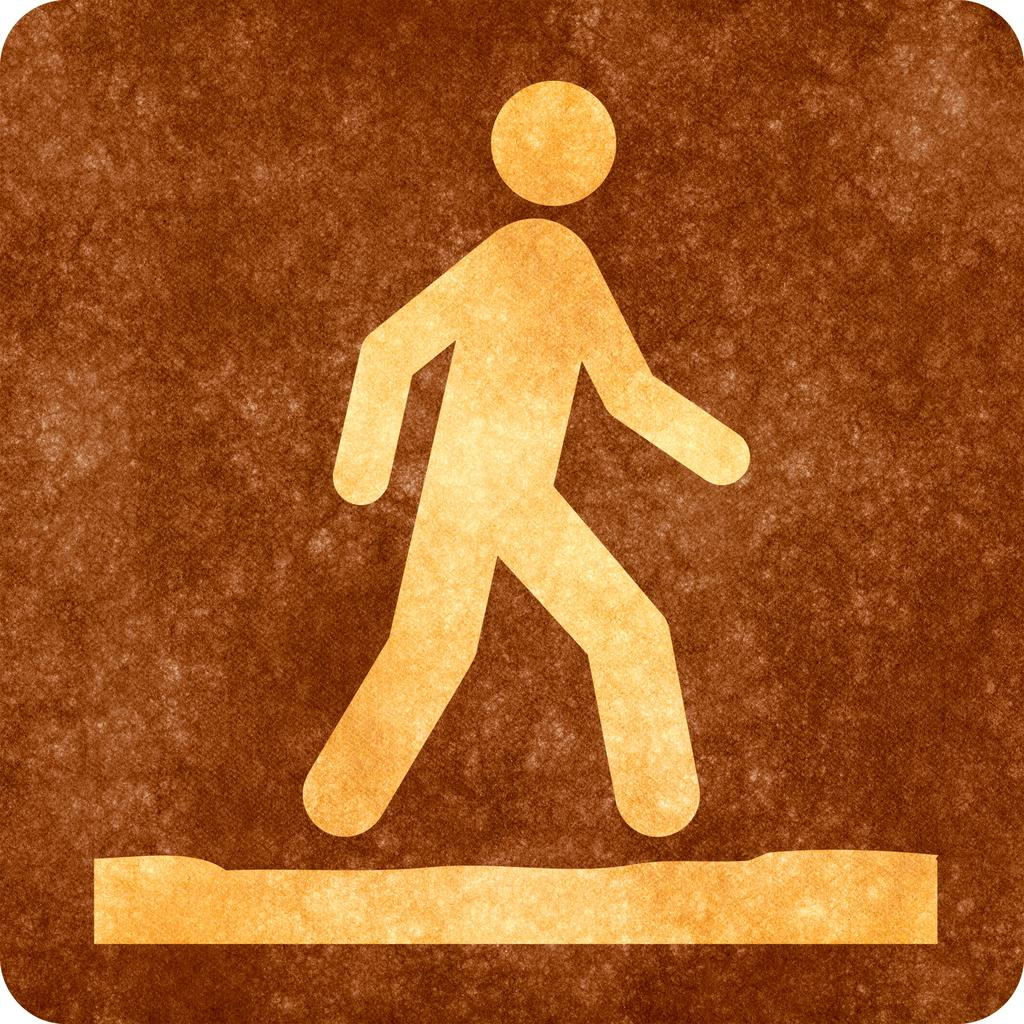What is the main object in the image? There is a sign board in the image. What is depicted on the sign board? The sign board has a picture of a person walking. What is the purpose or meaning of the sign board? The meaning of the sign board is walking. What type of produce is being sold at the store in the image? There is no store or produce present in the image; it only features a sign board with a picture of a person walking. What kind of pets can be seen in the image? There are no pets visible in the image; it only features a sign board with a picture of a person walking. 